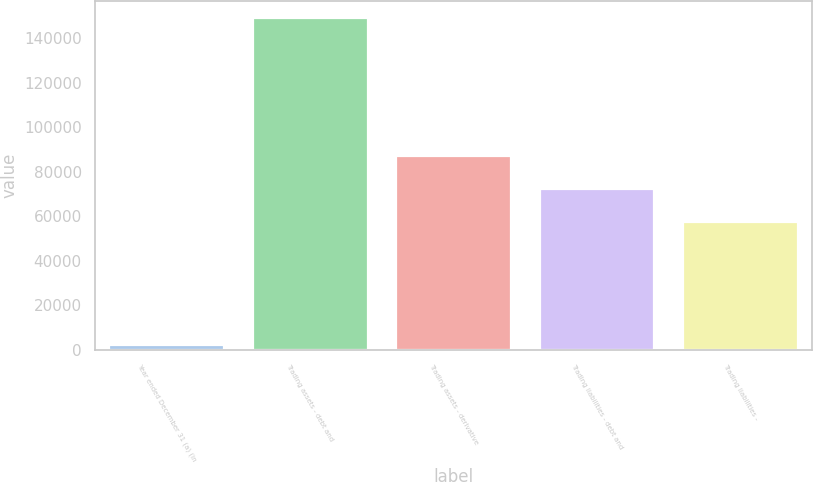Convert chart to OTSL. <chart><loc_0><loc_0><loc_500><loc_500><bar_chart><fcel>Year ended December 31 (a) (in<fcel>Trading assets - debt and<fcel>Trading assets - derivative<fcel>Trading liabilities - debt and<fcel>Trading liabilities -<nl><fcel>2002<fcel>149173<fcel>87041.2<fcel>72324.1<fcel>57607<nl></chart> 